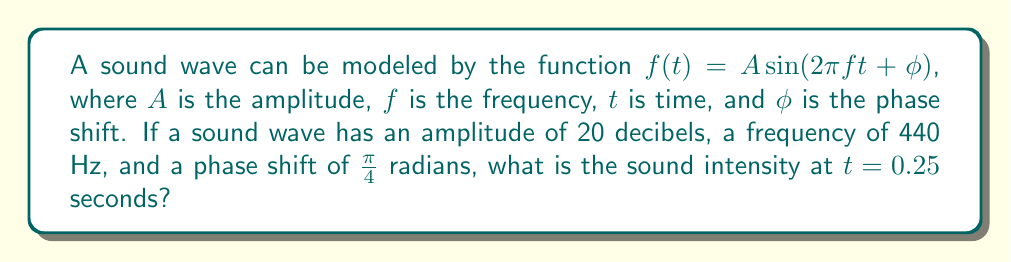Teach me how to tackle this problem. Let's approach this step-by-step:

1) We're given the general form of the sound wave function:
   $f(t) = A \sin(2\pi ft + \phi)$

2) We know the following values:
   $A = 20$ (amplitude in decibels)
   $f = 440$ Hz (frequency)
   $\phi = \frac{\pi}{4}$ radians (phase shift)
   $t = 0.25$ seconds

3) Let's substitute these values into our function:
   $f(0.25) = 20 \sin(2\pi(440)(0.25) + \frac{\pi}{4})$

4) Let's simplify the inside of the sine function first:
   $2\pi(440)(0.25) = 220\pi$

5) Now our function looks like this:
   $f(0.25) = 20 \sin(220\pi + \frac{\pi}{4})$

6) $220\pi$ is equivalent to $0$ in the sine function (since sine has a period of $2\pi$), so we can simplify:
   $f(0.25) = 20 \sin(\frac{\pi}{4})$

7) We know that $\sin(\frac{\pi}{4}) = \frac{\sqrt{2}}{2}$

8) Therefore:
   $f(0.25) = 20 \cdot \frac{\sqrt{2}}{2} = 10\sqrt{2}$ decibels

Thus, the sound intensity at $t = 0.25$ seconds is $10\sqrt{2}$ decibels.
Answer: $10\sqrt{2}$ decibels 